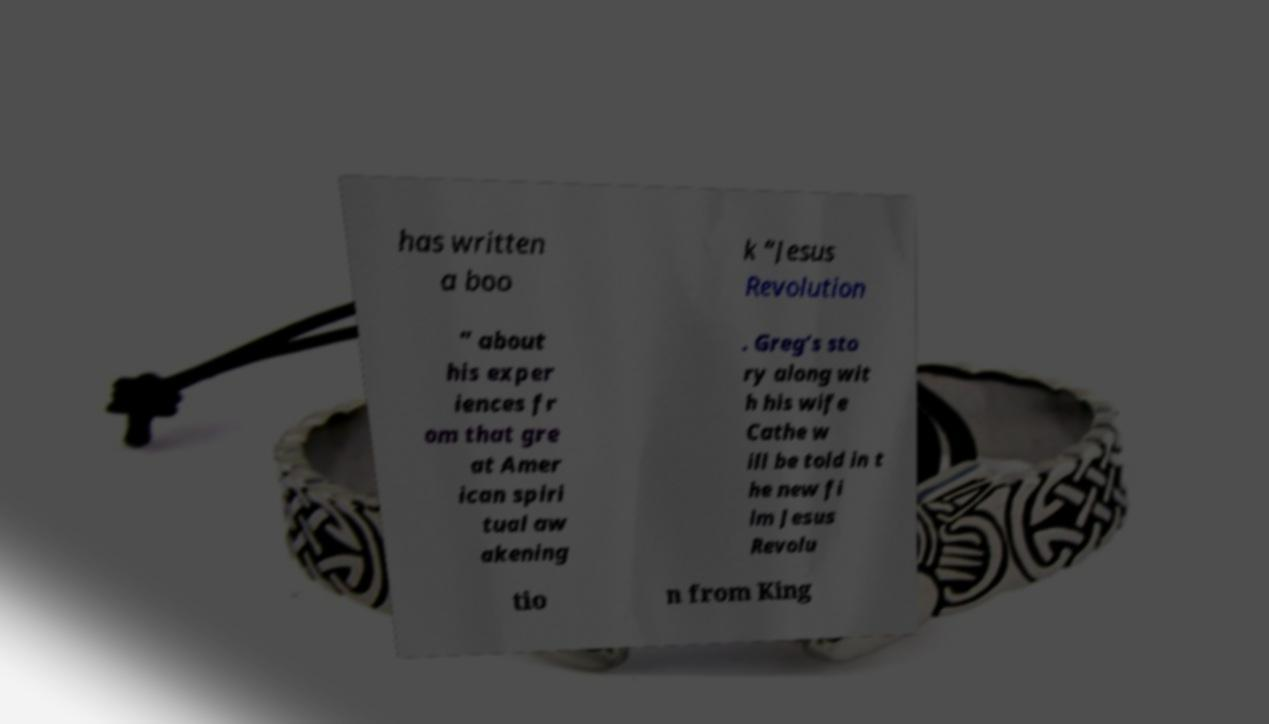Please identify and transcribe the text found in this image. has written a boo k “Jesus Revolution ” about his exper iences fr om that gre at Amer ican spiri tual aw akening . Greg’s sto ry along wit h his wife Cathe w ill be told in t he new fi lm Jesus Revolu tio n from King 